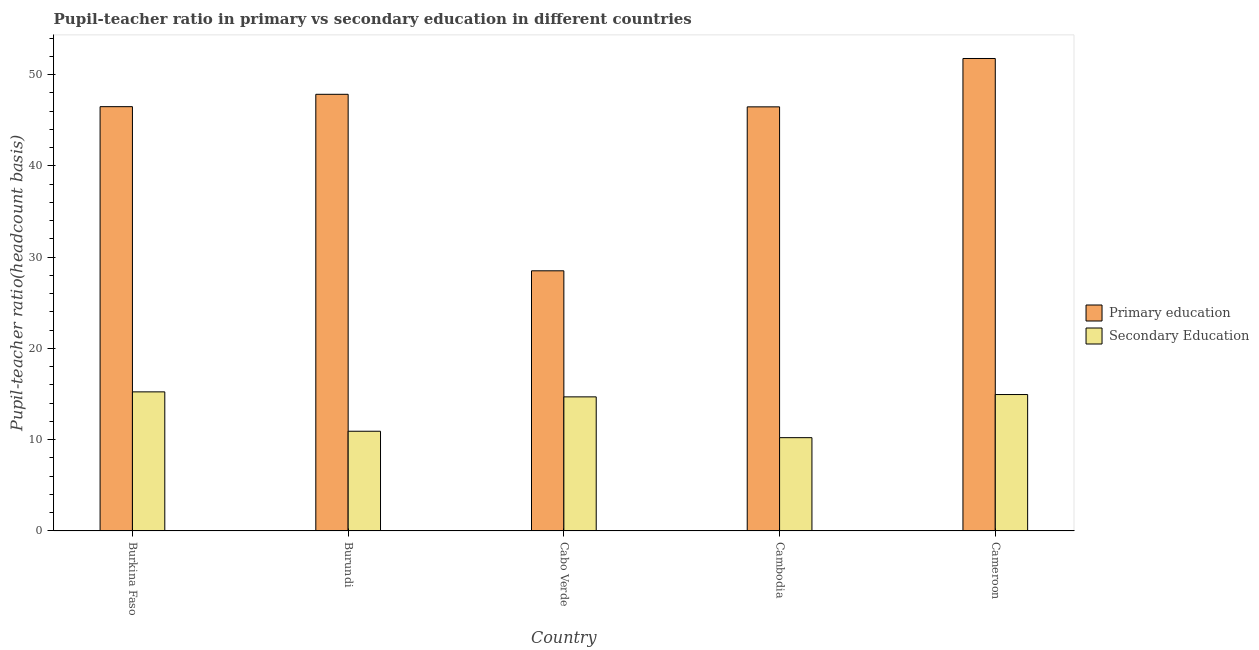How many different coloured bars are there?
Give a very brief answer. 2. How many groups of bars are there?
Give a very brief answer. 5. How many bars are there on the 5th tick from the left?
Provide a short and direct response. 2. What is the label of the 3rd group of bars from the left?
Your answer should be very brief. Cabo Verde. What is the pupil-teacher ratio in primary education in Cameroon?
Keep it short and to the point. 51.78. Across all countries, what is the maximum pupil-teacher ratio in primary education?
Provide a succinct answer. 51.78. Across all countries, what is the minimum pupil teacher ratio on secondary education?
Ensure brevity in your answer.  10.22. In which country was the pupil teacher ratio on secondary education maximum?
Ensure brevity in your answer.  Burkina Faso. In which country was the pupil teacher ratio on secondary education minimum?
Keep it short and to the point. Cambodia. What is the total pupil teacher ratio on secondary education in the graph?
Offer a terse response. 66.04. What is the difference between the pupil-teacher ratio in primary education in Burkina Faso and that in Burundi?
Give a very brief answer. -1.35. What is the difference between the pupil teacher ratio on secondary education in Cambodia and the pupil-teacher ratio in primary education in Burkina Faso?
Provide a succinct answer. -36.28. What is the average pupil teacher ratio on secondary education per country?
Your response must be concise. 13.21. What is the difference between the pupil teacher ratio on secondary education and pupil-teacher ratio in primary education in Burundi?
Your answer should be very brief. -36.93. What is the ratio of the pupil teacher ratio on secondary education in Burundi to that in Cabo Verde?
Give a very brief answer. 0.74. Is the pupil-teacher ratio in primary education in Burundi less than that in Cambodia?
Provide a short and direct response. No. Is the difference between the pupil-teacher ratio in primary education in Burkina Faso and Cabo Verde greater than the difference between the pupil teacher ratio on secondary education in Burkina Faso and Cabo Verde?
Offer a very short reply. Yes. What is the difference between the highest and the second highest pupil-teacher ratio in primary education?
Your response must be concise. 3.93. What is the difference between the highest and the lowest pupil-teacher ratio in primary education?
Your response must be concise. 23.27. In how many countries, is the pupil-teacher ratio in primary education greater than the average pupil-teacher ratio in primary education taken over all countries?
Your answer should be very brief. 4. What does the 2nd bar from the left in Burkina Faso represents?
Provide a short and direct response. Secondary Education. How many bars are there?
Provide a short and direct response. 10. Does the graph contain any zero values?
Offer a very short reply. No. Does the graph contain grids?
Ensure brevity in your answer.  No. How many legend labels are there?
Your answer should be compact. 2. How are the legend labels stacked?
Ensure brevity in your answer.  Vertical. What is the title of the graph?
Offer a very short reply. Pupil-teacher ratio in primary vs secondary education in different countries. Does "Attending school" appear as one of the legend labels in the graph?
Keep it short and to the point. No. What is the label or title of the X-axis?
Give a very brief answer. Country. What is the label or title of the Y-axis?
Offer a very short reply. Pupil-teacher ratio(headcount basis). What is the Pupil-teacher ratio(headcount basis) of Primary education in Burkina Faso?
Make the answer very short. 46.5. What is the Pupil-teacher ratio(headcount basis) of Secondary Education in Burkina Faso?
Provide a short and direct response. 15.24. What is the Pupil-teacher ratio(headcount basis) in Primary education in Burundi?
Provide a succinct answer. 47.86. What is the Pupil-teacher ratio(headcount basis) in Secondary Education in Burundi?
Your response must be concise. 10.93. What is the Pupil-teacher ratio(headcount basis) of Primary education in Cabo Verde?
Give a very brief answer. 28.51. What is the Pupil-teacher ratio(headcount basis) of Secondary Education in Cabo Verde?
Keep it short and to the point. 14.7. What is the Pupil-teacher ratio(headcount basis) in Primary education in Cambodia?
Keep it short and to the point. 46.48. What is the Pupil-teacher ratio(headcount basis) of Secondary Education in Cambodia?
Your answer should be very brief. 10.22. What is the Pupil-teacher ratio(headcount basis) in Primary education in Cameroon?
Provide a succinct answer. 51.78. What is the Pupil-teacher ratio(headcount basis) in Secondary Education in Cameroon?
Offer a very short reply. 14.95. Across all countries, what is the maximum Pupil-teacher ratio(headcount basis) in Primary education?
Provide a succinct answer. 51.78. Across all countries, what is the maximum Pupil-teacher ratio(headcount basis) in Secondary Education?
Keep it short and to the point. 15.24. Across all countries, what is the minimum Pupil-teacher ratio(headcount basis) in Primary education?
Keep it short and to the point. 28.51. Across all countries, what is the minimum Pupil-teacher ratio(headcount basis) of Secondary Education?
Make the answer very short. 10.22. What is the total Pupil-teacher ratio(headcount basis) in Primary education in the graph?
Your answer should be compact. 221.13. What is the total Pupil-teacher ratio(headcount basis) of Secondary Education in the graph?
Provide a short and direct response. 66.04. What is the difference between the Pupil-teacher ratio(headcount basis) of Primary education in Burkina Faso and that in Burundi?
Offer a very short reply. -1.35. What is the difference between the Pupil-teacher ratio(headcount basis) in Secondary Education in Burkina Faso and that in Burundi?
Make the answer very short. 4.32. What is the difference between the Pupil-teacher ratio(headcount basis) of Primary education in Burkina Faso and that in Cabo Verde?
Give a very brief answer. 17.99. What is the difference between the Pupil-teacher ratio(headcount basis) of Secondary Education in Burkina Faso and that in Cabo Verde?
Your response must be concise. 0.55. What is the difference between the Pupil-teacher ratio(headcount basis) in Primary education in Burkina Faso and that in Cambodia?
Provide a short and direct response. 0.02. What is the difference between the Pupil-teacher ratio(headcount basis) in Secondary Education in Burkina Faso and that in Cambodia?
Make the answer very short. 5.02. What is the difference between the Pupil-teacher ratio(headcount basis) of Primary education in Burkina Faso and that in Cameroon?
Your answer should be very brief. -5.28. What is the difference between the Pupil-teacher ratio(headcount basis) of Secondary Education in Burkina Faso and that in Cameroon?
Your answer should be compact. 0.29. What is the difference between the Pupil-teacher ratio(headcount basis) of Primary education in Burundi and that in Cabo Verde?
Offer a very short reply. 19.34. What is the difference between the Pupil-teacher ratio(headcount basis) in Secondary Education in Burundi and that in Cabo Verde?
Your response must be concise. -3.77. What is the difference between the Pupil-teacher ratio(headcount basis) of Primary education in Burundi and that in Cambodia?
Make the answer very short. 1.38. What is the difference between the Pupil-teacher ratio(headcount basis) in Secondary Education in Burundi and that in Cambodia?
Make the answer very short. 0.7. What is the difference between the Pupil-teacher ratio(headcount basis) of Primary education in Burundi and that in Cameroon?
Give a very brief answer. -3.93. What is the difference between the Pupil-teacher ratio(headcount basis) in Secondary Education in Burundi and that in Cameroon?
Offer a terse response. -4.02. What is the difference between the Pupil-teacher ratio(headcount basis) in Primary education in Cabo Verde and that in Cambodia?
Offer a terse response. -17.97. What is the difference between the Pupil-teacher ratio(headcount basis) in Secondary Education in Cabo Verde and that in Cambodia?
Make the answer very short. 4.47. What is the difference between the Pupil-teacher ratio(headcount basis) in Primary education in Cabo Verde and that in Cameroon?
Provide a succinct answer. -23.27. What is the difference between the Pupil-teacher ratio(headcount basis) of Secondary Education in Cabo Verde and that in Cameroon?
Provide a short and direct response. -0.25. What is the difference between the Pupil-teacher ratio(headcount basis) in Primary education in Cambodia and that in Cameroon?
Offer a terse response. -5.3. What is the difference between the Pupil-teacher ratio(headcount basis) of Secondary Education in Cambodia and that in Cameroon?
Make the answer very short. -4.73. What is the difference between the Pupil-teacher ratio(headcount basis) in Primary education in Burkina Faso and the Pupil-teacher ratio(headcount basis) in Secondary Education in Burundi?
Ensure brevity in your answer.  35.57. What is the difference between the Pupil-teacher ratio(headcount basis) in Primary education in Burkina Faso and the Pupil-teacher ratio(headcount basis) in Secondary Education in Cabo Verde?
Offer a very short reply. 31.81. What is the difference between the Pupil-teacher ratio(headcount basis) in Primary education in Burkina Faso and the Pupil-teacher ratio(headcount basis) in Secondary Education in Cambodia?
Offer a very short reply. 36.28. What is the difference between the Pupil-teacher ratio(headcount basis) of Primary education in Burkina Faso and the Pupil-teacher ratio(headcount basis) of Secondary Education in Cameroon?
Provide a succinct answer. 31.55. What is the difference between the Pupil-teacher ratio(headcount basis) in Primary education in Burundi and the Pupil-teacher ratio(headcount basis) in Secondary Education in Cabo Verde?
Give a very brief answer. 33.16. What is the difference between the Pupil-teacher ratio(headcount basis) of Primary education in Burundi and the Pupil-teacher ratio(headcount basis) of Secondary Education in Cambodia?
Provide a short and direct response. 37.63. What is the difference between the Pupil-teacher ratio(headcount basis) in Primary education in Burundi and the Pupil-teacher ratio(headcount basis) in Secondary Education in Cameroon?
Offer a terse response. 32.91. What is the difference between the Pupil-teacher ratio(headcount basis) of Primary education in Cabo Verde and the Pupil-teacher ratio(headcount basis) of Secondary Education in Cambodia?
Offer a terse response. 18.29. What is the difference between the Pupil-teacher ratio(headcount basis) of Primary education in Cabo Verde and the Pupil-teacher ratio(headcount basis) of Secondary Education in Cameroon?
Your answer should be compact. 13.56. What is the difference between the Pupil-teacher ratio(headcount basis) of Primary education in Cambodia and the Pupil-teacher ratio(headcount basis) of Secondary Education in Cameroon?
Offer a terse response. 31.53. What is the average Pupil-teacher ratio(headcount basis) of Primary education per country?
Provide a short and direct response. 44.23. What is the average Pupil-teacher ratio(headcount basis) of Secondary Education per country?
Give a very brief answer. 13.21. What is the difference between the Pupil-teacher ratio(headcount basis) of Primary education and Pupil-teacher ratio(headcount basis) of Secondary Education in Burkina Faso?
Provide a short and direct response. 31.26. What is the difference between the Pupil-teacher ratio(headcount basis) in Primary education and Pupil-teacher ratio(headcount basis) in Secondary Education in Burundi?
Offer a very short reply. 36.93. What is the difference between the Pupil-teacher ratio(headcount basis) of Primary education and Pupil-teacher ratio(headcount basis) of Secondary Education in Cabo Verde?
Your answer should be very brief. 13.82. What is the difference between the Pupil-teacher ratio(headcount basis) of Primary education and Pupil-teacher ratio(headcount basis) of Secondary Education in Cambodia?
Your answer should be compact. 36.26. What is the difference between the Pupil-teacher ratio(headcount basis) in Primary education and Pupil-teacher ratio(headcount basis) in Secondary Education in Cameroon?
Provide a short and direct response. 36.83. What is the ratio of the Pupil-teacher ratio(headcount basis) of Primary education in Burkina Faso to that in Burundi?
Provide a short and direct response. 0.97. What is the ratio of the Pupil-teacher ratio(headcount basis) of Secondary Education in Burkina Faso to that in Burundi?
Ensure brevity in your answer.  1.4. What is the ratio of the Pupil-teacher ratio(headcount basis) in Primary education in Burkina Faso to that in Cabo Verde?
Provide a short and direct response. 1.63. What is the ratio of the Pupil-teacher ratio(headcount basis) in Secondary Education in Burkina Faso to that in Cabo Verde?
Your answer should be compact. 1.04. What is the ratio of the Pupil-teacher ratio(headcount basis) in Secondary Education in Burkina Faso to that in Cambodia?
Keep it short and to the point. 1.49. What is the ratio of the Pupil-teacher ratio(headcount basis) of Primary education in Burkina Faso to that in Cameroon?
Provide a succinct answer. 0.9. What is the ratio of the Pupil-teacher ratio(headcount basis) of Secondary Education in Burkina Faso to that in Cameroon?
Ensure brevity in your answer.  1.02. What is the ratio of the Pupil-teacher ratio(headcount basis) in Primary education in Burundi to that in Cabo Verde?
Provide a short and direct response. 1.68. What is the ratio of the Pupil-teacher ratio(headcount basis) in Secondary Education in Burundi to that in Cabo Verde?
Make the answer very short. 0.74. What is the ratio of the Pupil-teacher ratio(headcount basis) of Primary education in Burundi to that in Cambodia?
Keep it short and to the point. 1.03. What is the ratio of the Pupil-teacher ratio(headcount basis) in Secondary Education in Burundi to that in Cambodia?
Ensure brevity in your answer.  1.07. What is the ratio of the Pupil-teacher ratio(headcount basis) of Primary education in Burundi to that in Cameroon?
Ensure brevity in your answer.  0.92. What is the ratio of the Pupil-teacher ratio(headcount basis) of Secondary Education in Burundi to that in Cameroon?
Provide a short and direct response. 0.73. What is the ratio of the Pupil-teacher ratio(headcount basis) in Primary education in Cabo Verde to that in Cambodia?
Keep it short and to the point. 0.61. What is the ratio of the Pupil-teacher ratio(headcount basis) of Secondary Education in Cabo Verde to that in Cambodia?
Provide a short and direct response. 1.44. What is the ratio of the Pupil-teacher ratio(headcount basis) in Primary education in Cabo Verde to that in Cameroon?
Offer a terse response. 0.55. What is the ratio of the Pupil-teacher ratio(headcount basis) of Primary education in Cambodia to that in Cameroon?
Give a very brief answer. 0.9. What is the ratio of the Pupil-teacher ratio(headcount basis) in Secondary Education in Cambodia to that in Cameroon?
Offer a terse response. 0.68. What is the difference between the highest and the second highest Pupil-teacher ratio(headcount basis) in Primary education?
Your answer should be compact. 3.93. What is the difference between the highest and the second highest Pupil-teacher ratio(headcount basis) of Secondary Education?
Make the answer very short. 0.29. What is the difference between the highest and the lowest Pupil-teacher ratio(headcount basis) of Primary education?
Provide a short and direct response. 23.27. What is the difference between the highest and the lowest Pupil-teacher ratio(headcount basis) in Secondary Education?
Ensure brevity in your answer.  5.02. 